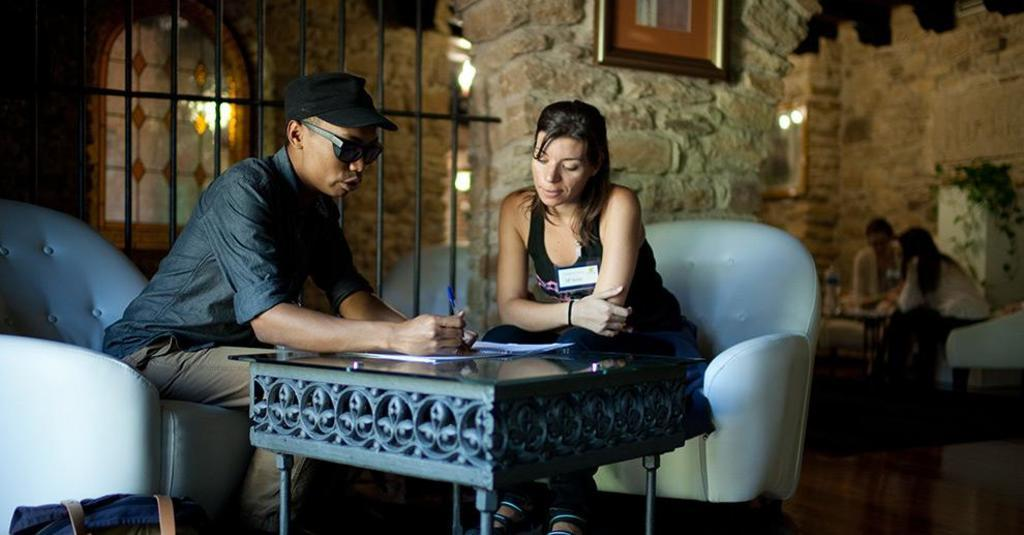What type of structure is visible in the image? There is a brick wall in the image. Who or what can be seen in the image? There are people in the image. What type of furniture is present in the image? There are chairs and a table in the image. What object is on the table in the image? There is a book on the table in the image. What month is it in the image? The image does not provide any information about the month or time of year. 